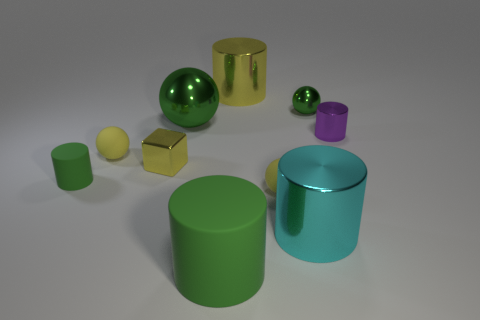What is the material of the tiny cylinder that is the same color as the large ball?
Give a very brief answer. Rubber. Is there any other thing that has the same shape as the small yellow metal object?
Offer a terse response. No. Is the number of balls greater than the number of yellow metallic objects?
Your answer should be compact. Yes. What number of other things are there of the same material as the big yellow thing
Your response must be concise. 5. The tiny yellow matte thing that is in front of the sphere on the left side of the yellow metal thing in front of the purple thing is what shape?
Make the answer very short. Sphere. Are there fewer shiny spheres that are to the right of the cyan metallic cylinder than metallic balls that are left of the purple cylinder?
Offer a very short reply. Yes. Are there any shiny cylinders of the same color as the small block?
Your answer should be compact. Yes. Is the material of the yellow cube the same as the tiny green object that is on the left side of the cyan metallic cylinder?
Your answer should be compact. No. Is there a small cube behind the object that is behind the small green shiny object?
Give a very brief answer. No. There is a rubber thing that is both right of the yellow shiny cube and behind the big green rubber thing; what color is it?
Your answer should be very brief. Yellow. 